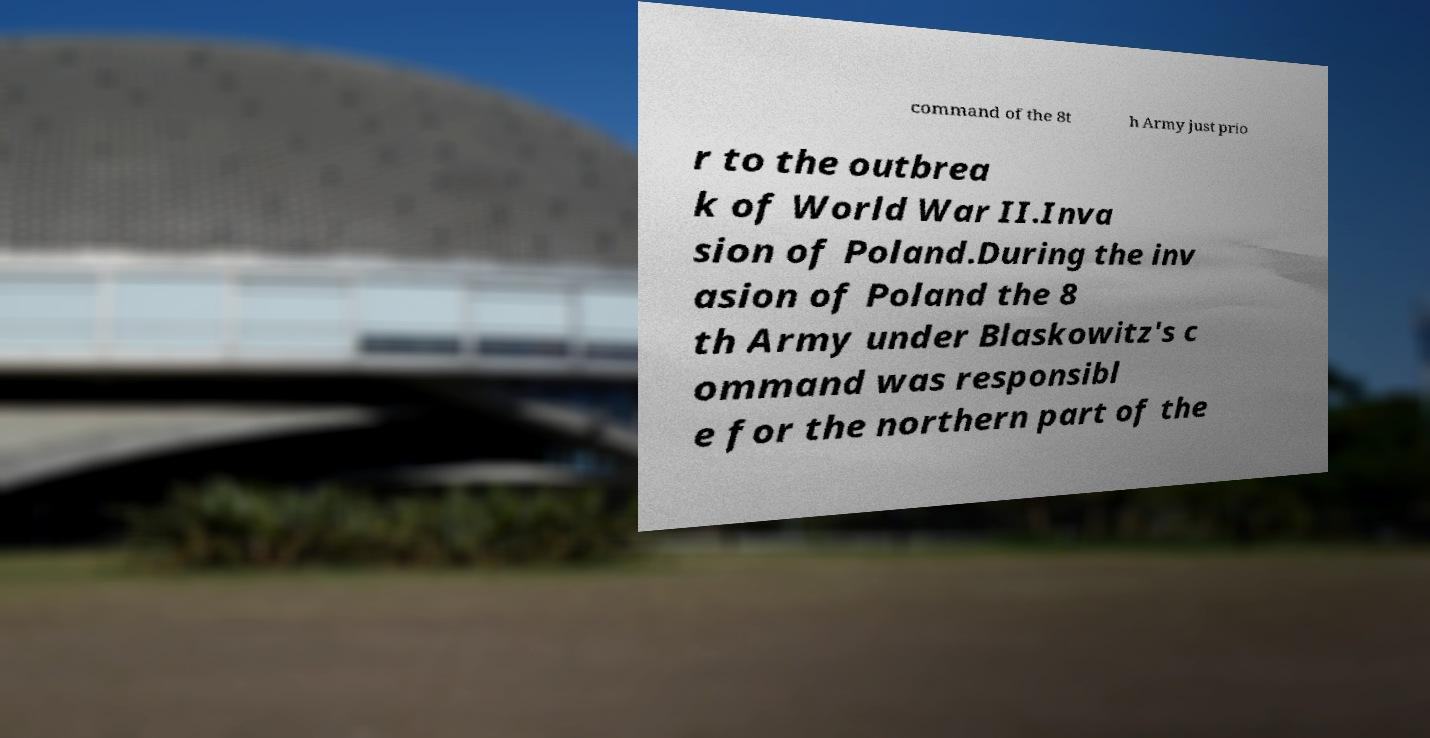Please read and relay the text visible in this image. What does it say? command of the 8t h Army just prio r to the outbrea k of World War II.Inva sion of Poland.During the inv asion of Poland the 8 th Army under Blaskowitz's c ommand was responsibl e for the northern part of the 